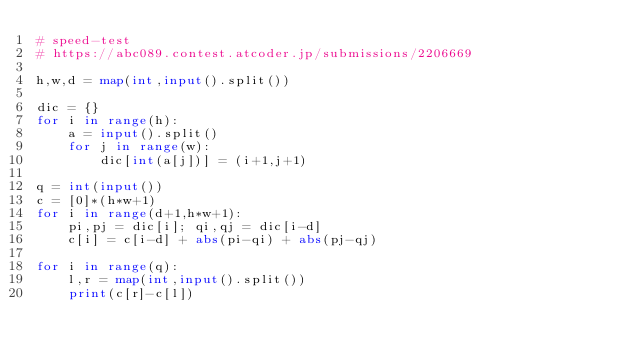<code> <loc_0><loc_0><loc_500><loc_500><_Python_># speed-test
# https://abc089.contest.atcoder.jp/submissions/2206669

h,w,d = map(int,input().split())
 
dic = {}
for i in range(h):
    a = input().split()
    for j in range(w):
        dic[int(a[j])] = (i+1,j+1)
        
q = int(input())
c = [0]*(h*w+1)
for i in range(d+1,h*w+1):
    pi,pj = dic[i]; qi,qj = dic[i-d]
    c[i] = c[i-d] + abs(pi-qi) + abs(pj-qj)
    
for i in range(q):
    l,r = map(int,input().split())
    print(c[r]-c[l])
</code> 